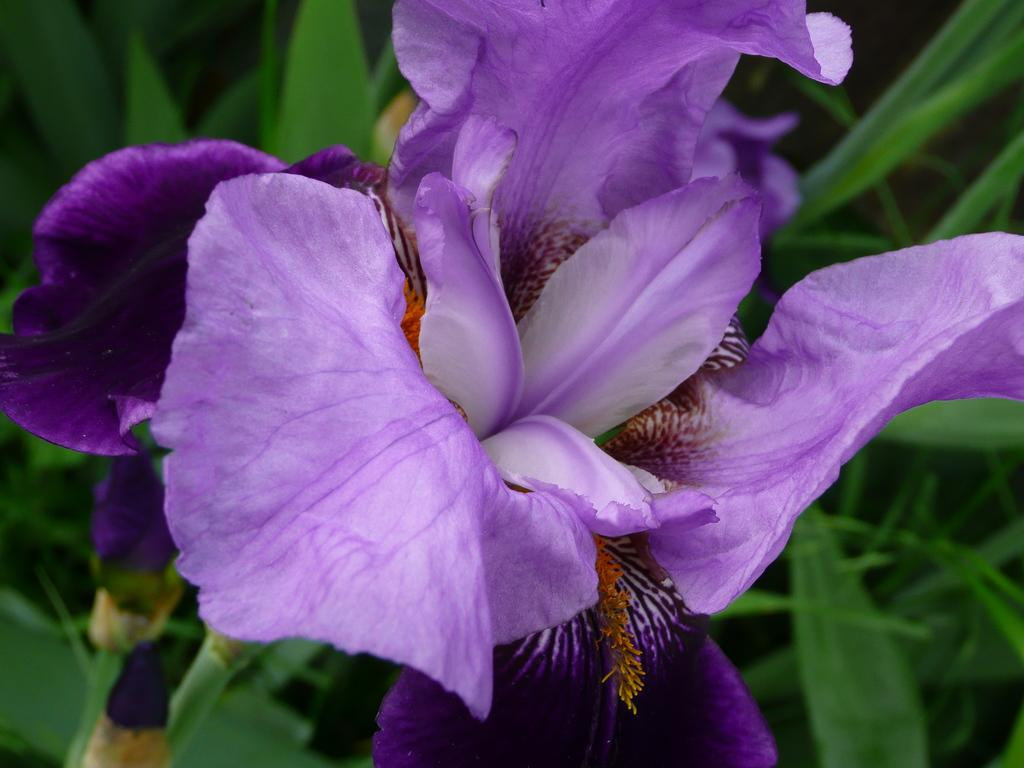What is the main subject of the image? There is a flower in the center of the image. What color is the flower? The flower is purple. What else can be seen in the background of the image? There are leaves in the background of the image. What type of agreement is being discussed in the image? There is no discussion or agreement present in the image; it features a purple flower and leaves in the background. 